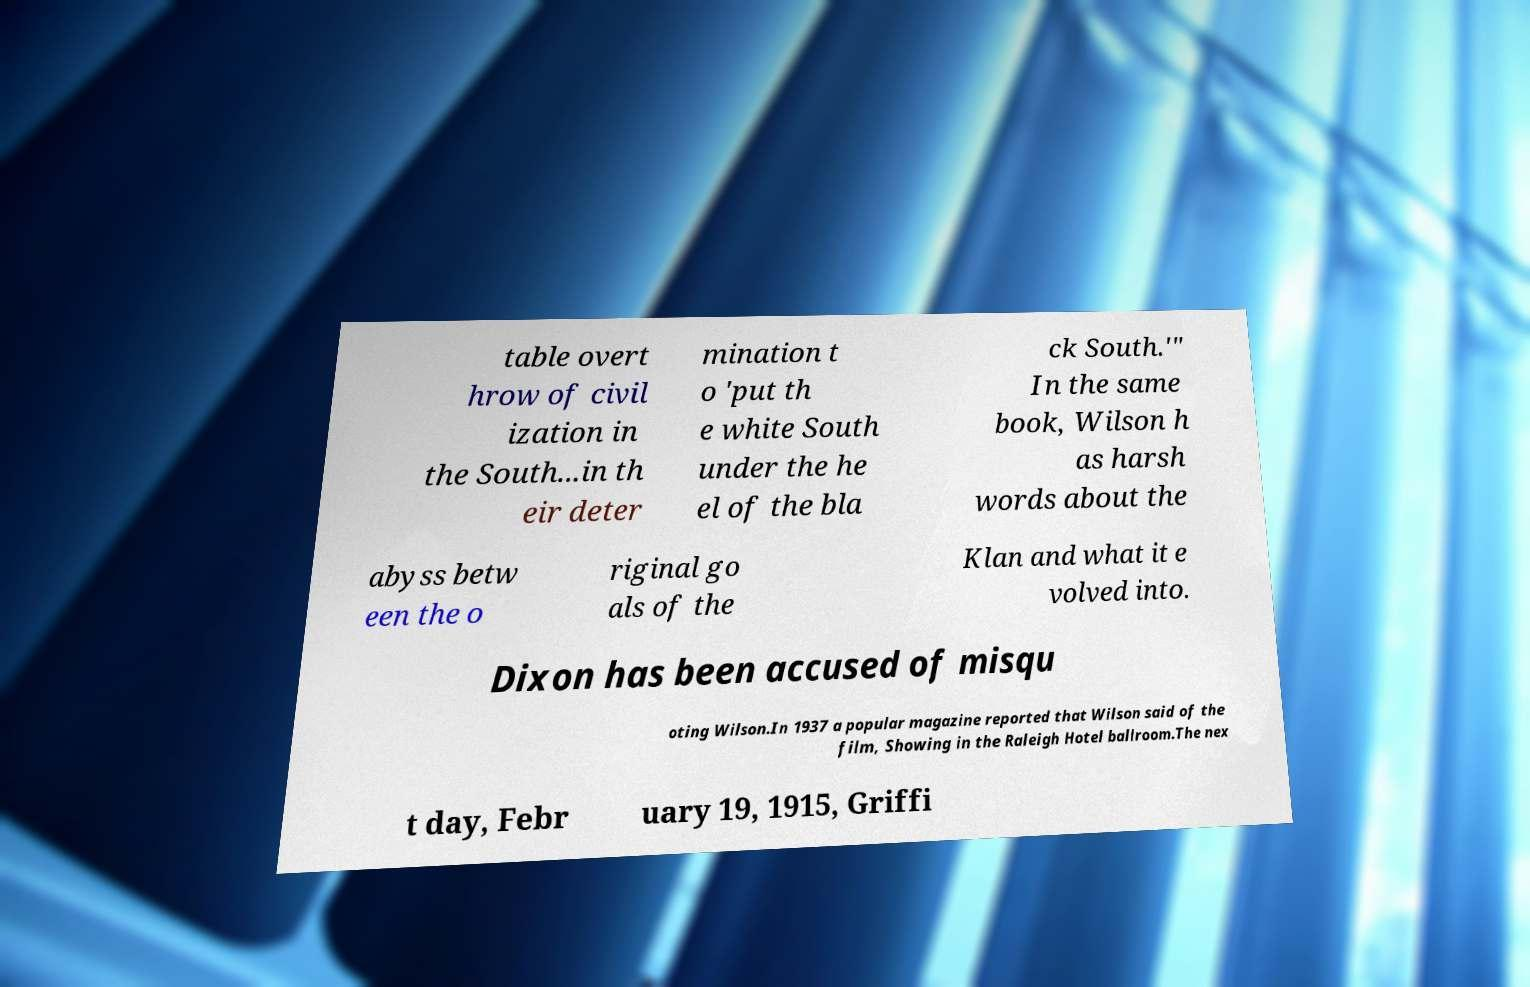Please read and relay the text visible in this image. What does it say? table overt hrow of civil ization in the South...in th eir deter mination t o 'put th e white South under the he el of the bla ck South.'" In the same book, Wilson h as harsh words about the abyss betw een the o riginal go als of the Klan and what it e volved into. Dixon has been accused of misqu oting Wilson.In 1937 a popular magazine reported that Wilson said of the film, Showing in the Raleigh Hotel ballroom.The nex t day, Febr uary 19, 1915, Griffi 